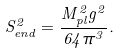<formula> <loc_0><loc_0><loc_500><loc_500>S _ { e n d } ^ { 2 } = { \frac { M _ { p l } ^ { 2 } g ^ { 2 } } { 6 4 \pi ^ { 3 } } } .</formula> 